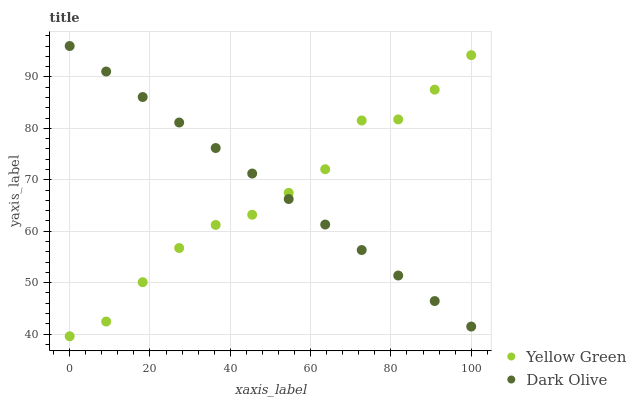Does Yellow Green have the minimum area under the curve?
Answer yes or no. Yes. Does Dark Olive have the maximum area under the curve?
Answer yes or no. Yes. Does Yellow Green have the maximum area under the curve?
Answer yes or no. No. Is Dark Olive the smoothest?
Answer yes or no. Yes. Is Yellow Green the roughest?
Answer yes or no. Yes. Is Yellow Green the smoothest?
Answer yes or no. No. Does Yellow Green have the lowest value?
Answer yes or no. Yes. Does Dark Olive have the highest value?
Answer yes or no. Yes. Does Yellow Green have the highest value?
Answer yes or no. No. Does Yellow Green intersect Dark Olive?
Answer yes or no. Yes. Is Yellow Green less than Dark Olive?
Answer yes or no. No. Is Yellow Green greater than Dark Olive?
Answer yes or no. No. 